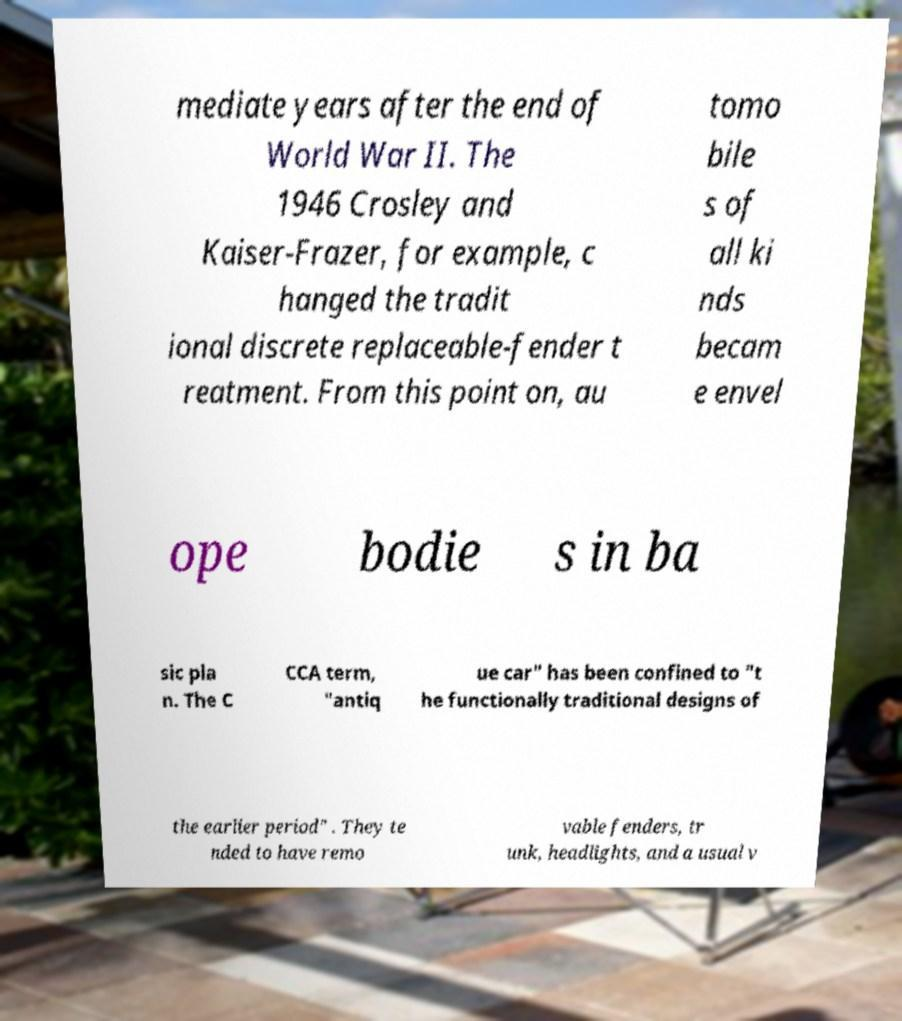Can you read and provide the text displayed in the image?This photo seems to have some interesting text. Can you extract and type it out for me? mediate years after the end of World War II. The 1946 Crosley and Kaiser-Frazer, for example, c hanged the tradit ional discrete replaceable-fender t reatment. From this point on, au tomo bile s of all ki nds becam e envel ope bodie s in ba sic pla n. The C CCA term, "antiq ue car" has been confined to "t he functionally traditional designs of the earlier period" . They te nded to have remo vable fenders, tr unk, headlights, and a usual v 